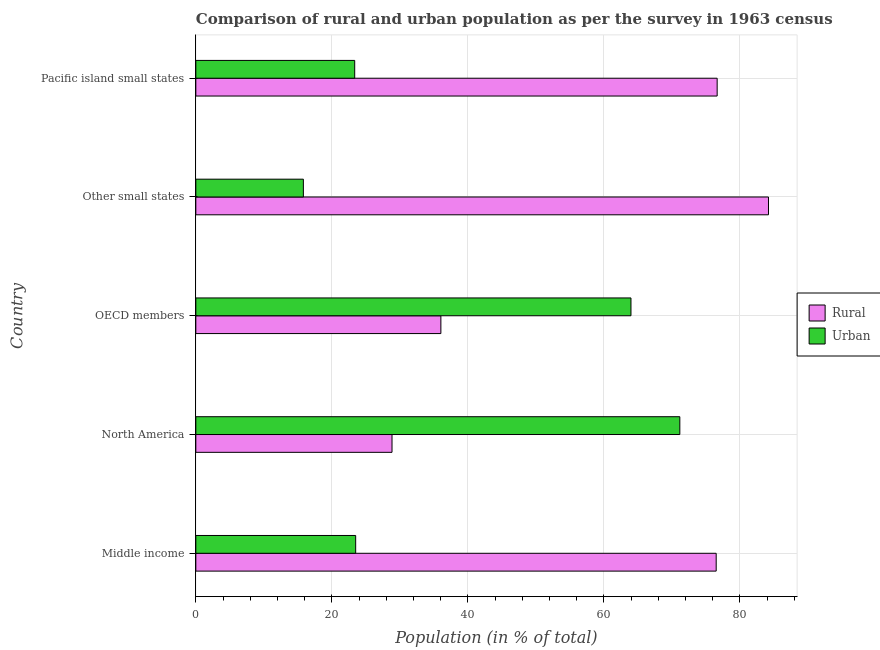Are the number of bars per tick equal to the number of legend labels?
Keep it short and to the point. Yes. Are the number of bars on each tick of the Y-axis equal?
Make the answer very short. Yes. How many bars are there on the 1st tick from the top?
Give a very brief answer. 2. How many bars are there on the 5th tick from the bottom?
Provide a short and direct response. 2. What is the label of the 4th group of bars from the top?
Keep it short and to the point. North America. What is the urban population in Other small states?
Your answer should be compact. 15.81. Across all countries, what is the maximum urban population?
Your answer should be very brief. 71.16. Across all countries, what is the minimum urban population?
Offer a terse response. 15.81. In which country was the rural population maximum?
Your response must be concise. Other small states. In which country was the urban population minimum?
Provide a succinct answer. Other small states. What is the total rural population in the graph?
Your answer should be compact. 302.2. What is the difference between the urban population in OECD members and that in Pacific island small states?
Provide a short and direct response. 40.62. What is the difference between the urban population in Middle income and the rural population in OECD members?
Offer a terse response. -12.53. What is the average urban population per country?
Your answer should be compact. 39.56. What is the difference between the rural population and urban population in North America?
Offer a very short reply. -42.31. What is the ratio of the urban population in OECD members to that in Pacific island small states?
Keep it short and to the point. 2.74. What is the difference between the highest and the second highest urban population?
Your response must be concise. 7.18. What is the difference between the highest and the lowest urban population?
Provide a short and direct response. 55.35. What does the 2nd bar from the top in North America represents?
Keep it short and to the point. Rural. What does the 2nd bar from the bottom in North America represents?
Provide a short and direct response. Urban. How many bars are there?
Your answer should be very brief. 10. Are all the bars in the graph horizontal?
Make the answer very short. Yes. How many countries are there in the graph?
Your answer should be very brief. 5. What is the difference between two consecutive major ticks on the X-axis?
Offer a very short reply. 20. Does the graph contain grids?
Offer a very short reply. Yes. Where does the legend appear in the graph?
Your answer should be compact. Center right. How many legend labels are there?
Offer a very short reply. 2. What is the title of the graph?
Make the answer very short. Comparison of rural and urban population as per the survey in 1963 census. What is the label or title of the X-axis?
Provide a succinct answer. Population (in % of total). What is the label or title of the Y-axis?
Offer a very short reply. Country. What is the Population (in % of total) in Rural in Middle income?
Your answer should be compact. 76.5. What is the Population (in % of total) of Urban in Middle income?
Ensure brevity in your answer.  23.5. What is the Population (in % of total) in Rural in North America?
Provide a short and direct response. 28.84. What is the Population (in % of total) of Urban in North America?
Make the answer very short. 71.16. What is the Population (in % of total) in Rural in OECD members?
Ensure brevity in your answer.  36.03. What is the Population (in % of total) of Urban in OECD members?
Ensure brevity in your answer.  63.97. What is the Population (in % of total) in Rural in Other small states?
Keep it short and to the point. 84.19. What is the Population (in % of total) in Urban in Other small states?
Ensure brevity in your answer.  15.81. What is the Population (in % of total) of Rural in Pacific island small states?
Make the answer very short. 76.64. What is the Population (in % of total) of Urban in Pacific island small states?
Your answer should be compact. 23.36. Across all countries, what is the maximum Population (in % of total) of Rural?
Give a very brief answer. 84.19. Across all countries, what is the maximum Population (in % of total) in Urban?
Your response must be concise. 71.16. Across all countries, what is the minimum Population (in % of total) of Rural?
Give a very brief answer. 28.84. Across all countries, what is the minimum Population (in % of total) in Urban?
Keep it short and to the point. 15.81. What is the total Population (in % of total) in Rural in the graph?
Your answer should be compact. 302.2. What is the total Population (in % of total) of Urban in the graph?
Offer a terse response. 197.8. What is the difference between the Population (in % of total) in Rural in Middle income and that in North America?
Ensure brevity in your answer.  47.66. What is the difference between the Population (in % of total) in Urban in Middle income and that in North America?
Your answer should be very brief. -47.66. What is the difference between the Population (in % of total) of Rural in Middle income and that in OECD members?
Make the answer very short. 40.47. What is the difference between the Population (in % of total) of Urban in Middle income and that in OECD members?
Offer a very short reply. -40.47. What is the difference between the Population (in % of total) in Rural in Middle income and that in Other small states?
Provide a succinct answer. -7.69. What is the difference between the Population (in % of total) in Urban in Middle income and that in Other small states?
Your answer should be compact. 7.69. What is the difference between the Population (in % of total) of Rural in Middle income and that in Pacific island small states?
Your answer should be compact. -0.14. What is the difference between the Population (in % of total) of Urban in Middle income and that in Pacific island small states?
Your answer should be compact. 0.14. What is the difference between the Population (in % of total) of Rural in North America and that in OECD members?
Ensure brevity in your answer.  -7.18. What is the difference between the Population (in % of total) of Urban in North America and that in OECD members?
Your response must be concise. 7.18. What is the difference between the Population (in % of total) in Rural in North America and that in Other small states?
Your response must be concise. -55.35. What is the difference between the Population (in % of total) in Urban in North America and that in Other small states?
Keep it short and to the point. 55.35. What is the difference between the Population (in % of total) of Rural in North America and that in Pacific island small states?
Provide a succinct answer. -47.8. What is the difference between the Population (in % of total) of Urban in North America and that in Pacific island small states?
Provide a succinct answer. 47.8. What is the difference between the Population (in % of total) of Rural in OECD members and that in Other small states?
Offer a very short reply. -48.16. What is the difference between the Population (in % of total) in Urban in OECD members and that in Other small states?
Provide a succinct answer. 48.16. What is the difference between the Population (in % of total) of Rural in OECD members and that in Pacific island small states?
Keep it short and to the point. -40.62. What is the difference between the Population (in % of total) in Urban in OECD members and that in Pacific island small states?
Your answer should be compact. 40.62. What is the difference between the Population (in % of total) of Rural in Other small states and that in Pacific island small states?
Your response must be concise. 7.55. What is the difference between the Population (in % of total) in Urban in Other small states and that in Pacific island small states?
Provide a short and direct response. -7.55. What is the difference between the Population (in % of total) in Rural in Middle income and the Population (in % of total) in Urban in North America?
Keep it short and to the point. 5.34. What is the difference between the Population (in % of total) of Rural in Middle income and the Population (in % of total) of Urban in OECD members?
Provide a short and direct response. 12.53. What is the difference between the Population (in % of total) in Rural in Middle income and the Population (in % of total) in Urban in Other small states?
Provide a short and direct response. 60.69. What is the difference between the Population (in % of total) in Rural in Middle income and the Population (in % of total) in Urban in Pacific island small states?
Offer a very short reply. 53.14. What is the difference between the Population (in % of total) of Rural in North America and the Population (in % of total) of Urban in OECD members?
Your answer should be compact. -35.13. What is the difference between the Population (in % of total) of Rural in North America and the Population (in % of total) of Urban in Other small states?
Offer a very short reply. 13.03. What is the difference between the Population (in % of total) of Rural in North America and the Population (in % of total) of Urban in Pacific island small states?
Your response must be concise. 5.49. What is the difference between the Population (in % of total) in Rural in OECD members and the Population (in % of total) in Urban in Other small states?
Your answer should be compact. 20.22. What is the difference between the Population (in % of total) of Rural in OECD members and the Population (in % of total) of Urban in Pacific island small states?
Your answer should be compact. 12.67. What is the difference between the Population (in % of total) in Rural in Other small states and the Population (in % of total) in Urban in Pacific island small states?
Provide a short and direct response. 60.83. What is the average Population (in % of total) in Rural per country?
Provide a succinct answer. 60.44. What is the average Population (in % of total) of Urban per country?
Offer a terse response. 39.56. What is the difference between the Population (in % of total) in Rural and Population (in % of total) in Urban in Middle income?
Make the answer very short. 53. What is the difference between the Population (in % of total) of Rural and Population (in % of total) of Urban in North America?
Provide a succinct answer. -42.31. What is the difference between the Population (in % of total) in Rural and Population (in % of total) in Urban in OECD members?
Your response must be concise. -27.95. What is the difference between the Population (in % of total) in Rural and Population (in % of total) in Urban in Other small states?
Provide a short and direct response. 68.38. What is the difference between the Population (in % of total) of Rural and Population (in % of total) of Urban in Pacific island small states?
Offer a terse response. 53.29. What is the ratio of the Population (in % of total) in Rural in Middle income to that in North America?
Your answer should be compact. 2.65. What is the ratio of the Population (in % of total) in Urban in Middle income to that in North America?
Ensure brevity in your answer.  0.33. What is the ratio of the Population (in % of total) of Rural in Middle income to that in OECD members?
Offer a terse response. 2.12. What is the ratio of the Population (in % of total) of Urban in Middle income to that in OECD members?
Give a very brief answer. 0.37. What is the ratio of the Population (in % of total) of Rural in Middle income to that in Other small states?
Your response must be concise. 0.91. What is the ratio of the Population (in % of total) in Urban in Middle income to that in Other small states?
Ensure brevity in your answer.  1.49. What is the ratio of the Population (in % of total) in Rural in Middle income to that in Pacific island small states?
Keep it short and to the point. 1. What is the ratio of the Population (in % of total) of Urban in Middle income to that in Pacific island small states?
Your answer should be compact. 1.01. What is the ratio of the Population (in % of total) of Rural in North America to that in OECD members?
Your response must be concise. 0.8. What is the ratio of the Population (in % of total) of Urban in North America to that in OECD members?
Provide a short and direct response. 1.11. What is the ratio of the Population (in % of total) of Rural in North America to that in Other small states?
Provide a short and direct response. 0.34. What is the ratio of the Population (in % of total) in Urban in North America to that in Other small states?
Give a very brief answer. 4.5. What is the ratio of the Population (in % of total) of Rural in North America to that in Pacific island small states?
Offer a terse response. 0.38. What is the ratio of the Population (in % of total) of Urban in North America to that in Pacific island small states?
Make the answer very short. 3.05. What is the ratio of the Population (in % of total) in Rural in OECD members to that in Other small states?
Provide a succinct answer. 0.43. What is the ratio of the Population (in % of total) in Urban in OECD members to that in Other small states?
Keep it short and to the point. 4.05. What is the ratio of the Population (in % of total) of Rural in OECD members to that in Pacific island small states?
Ensure brevity in your answer.  0.47. What is the ratio of the Population (in % of total) of Urban in OECD members to that in Pacific island small states?
Offer a very short reply. 2.74. What is the ratio of the Population (in % of total) of Rural in Other small states to that in Pacific island small states?
Your response must be concise. 1.1. What is the ratio of the Population (in % of total) of Urban in Other small states to that in Pacific island small states?
Provide a succinct answer. 0.68. What is the difference between the highest and the second highest Population (in % of total) of Rural?
Keep it short and to the point. 7.55. What is the difference between the highest and the second highest Population (in % of total) of Urban?
Provide a succinct answer. 7.18. What is the difference between the highest and the lowest Population (in % of total) of Rural?
Make the answer very short. 55.35. What is the difference between the highest and the lowest Population (in % of total) of Urban?
Your answer should be very brief. 55.35. 